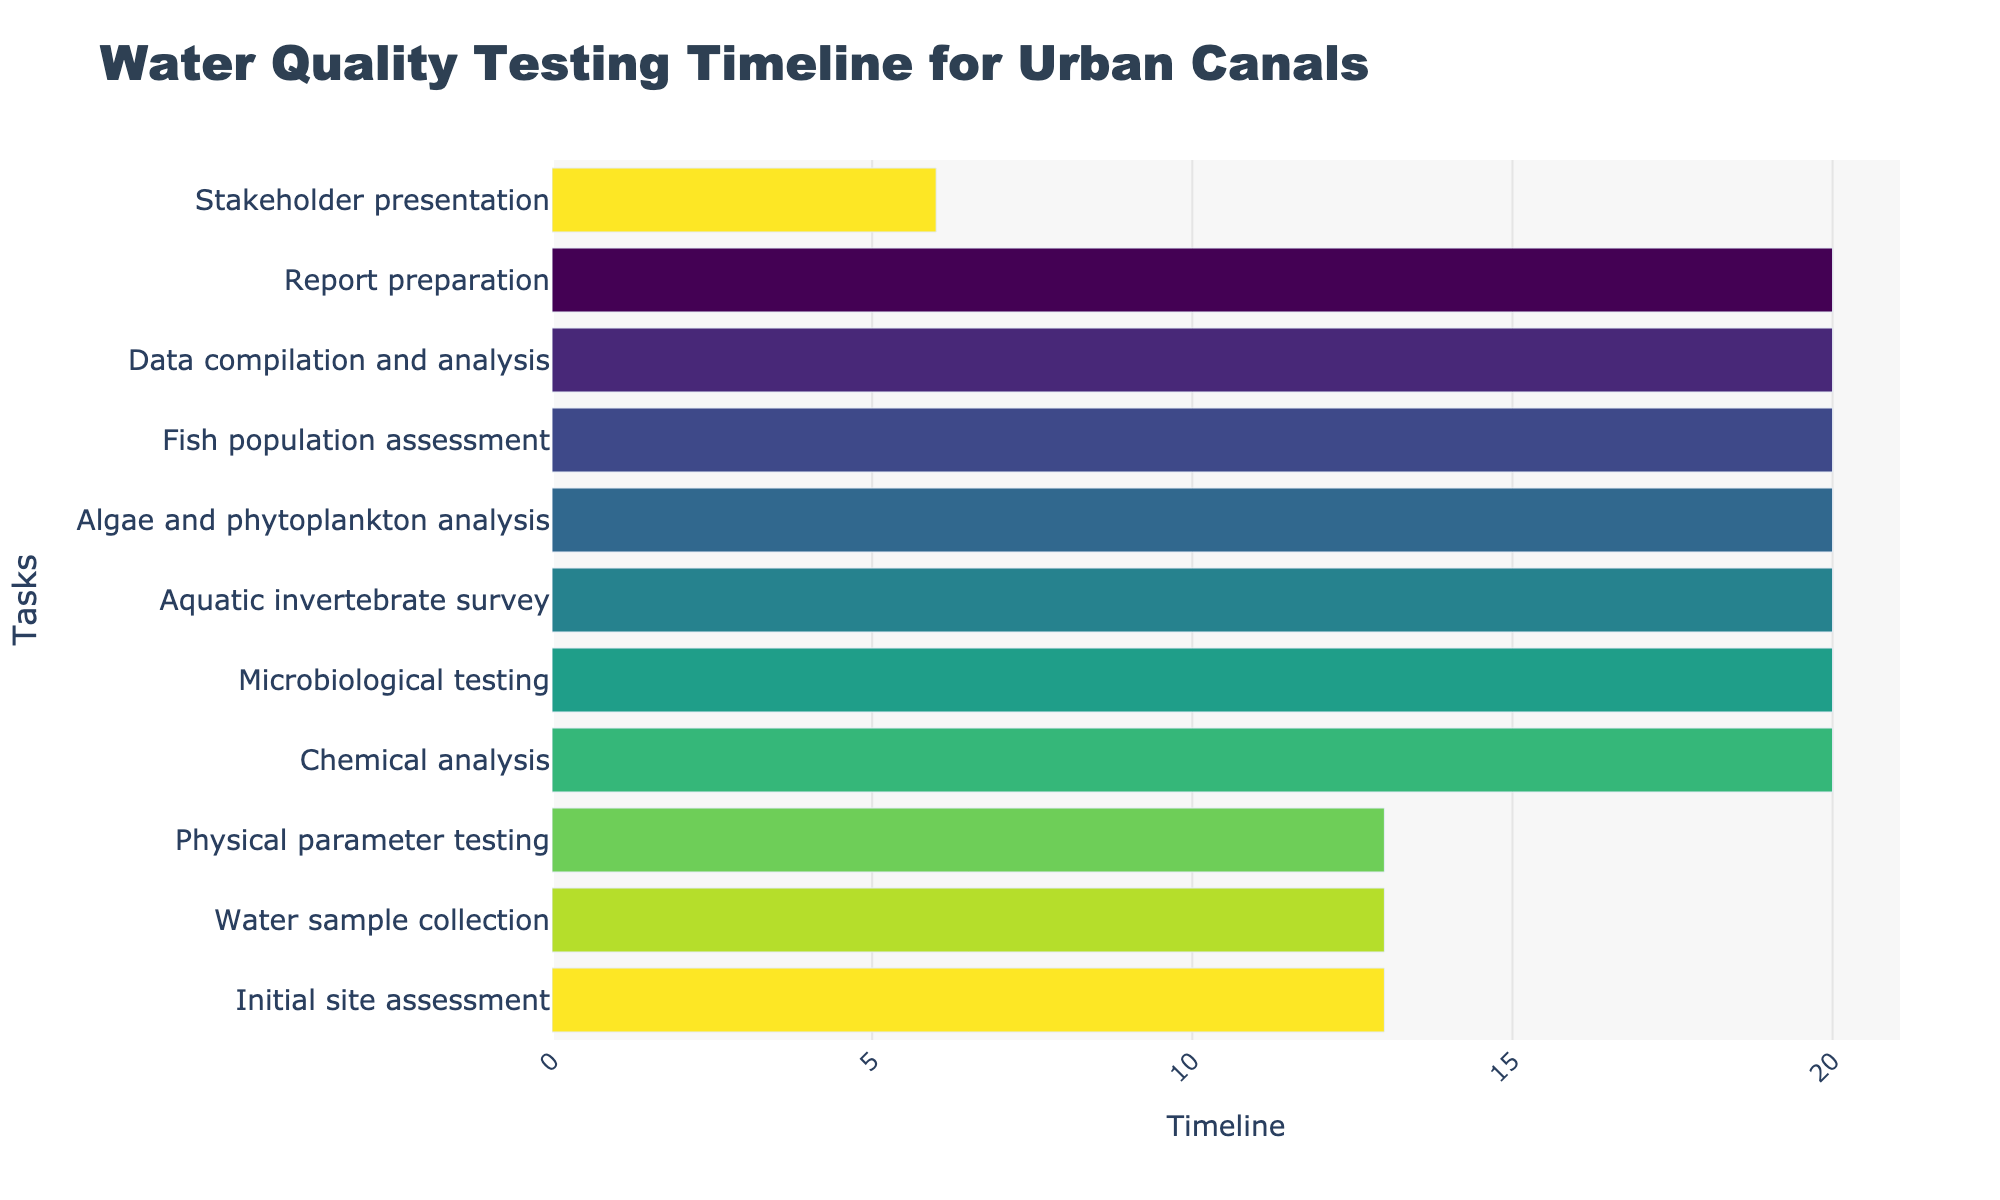What task is the first one to start? The first task is the one with the earliest start date. From the chart, "Initial site assessment" starts on 2023-05-01, which is the earliest date.
Answer: Initial site assessment Which task has the longest duration? To find the longest duration, we need to compare the duration of all tasks. "Chemical analysis" spans from 2023-06-12 to 2023-07-02, covering 21 days, which is the longest among all tasks.
Answer: Chemical analysis What's the total duration for all tasks combined? Sum the duration of all tasks: 14 (Initial site assessment) + 14 (Water sample collection) + 14 (Physical parameter testing) + 21 (Chemical analysis) + 21 (Microbiological testing) + 21 (Aquatic invertebrate survey) + 21 (Algae and phytoplankton analysis) + 21 (Fish population assessment) + 21 (Data compilation and analysis) + 21 (Report preparation) + 7 (Stakeholder presentation) = 196 days
Answer: 196 days When does the "Fish population assessment" task end? Check the end date of "Fish population assessment". It ends on 2023-09-24.
Answer: 2023-09-24 Which tasks overlap with the "Microbiological testing"? Analyze the timeline to see which tasks run concurrently with "Microbiological testing" (2023-07-03 to 2023-07-23). The task immediately following it is "Aquatic invertebrate survey" starting on 2023-07-24; hence, there is no direct overlap during these dates.
Answer: None How many tasks are scheduled to end after September 2023? Look at the end dates of all tasks. Tasks ending after September 2023 are "Data compilation and analysis" (ending 2023-10-15), "Report preparation" (ending 2023-11-05), and "Stakeholder presentation" (ending 2023-11-12).
Answer: 3 tasks On which date does "Algae and phytoplankton analysis" end? Check the end date of "Algae and phytoplankton analysis". According to the chart, it ends on 2023-09-03.
Answer: 2023-09-03 Compare the durations of "Water sample collection" and "Data compilation and analysis". Which has a longer duration? Compare the durations: "Water sample collection" (14 days) vs. "Data compilation and analysis" (21 days). "Data compilation and analysis" has a longer duration.
Answer: Data compilation and analysis Which tasks occur entirely within the month of July 2023? Check the tasks' start and end dates for July 2023. "Microbiological testing" occurs entirely from 2023-07-03 to 2023-07-23.
Answer: Microbiological testing What's the average duration of the tasks? First, calculate the total duration (196 days) and the number of tasks (11). The average duration is 196 / 11 = 17.8 days.
Answer: 17.8 days 